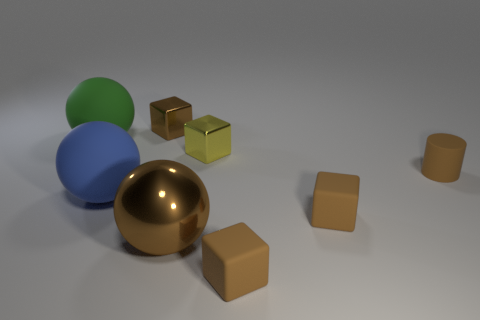Is the number of small brown shiny blocks that are left of the large blue ball the same as the number of blue metal cylinders?
Make the answer very short. Yes. What is the size of the green ball?
Your response must be concise. Large. There is a tiny metallic object that is behind the tiny yellow block; what number of tiny brown blocks are left of it?
Your answer should be compact. 0. What is the shape of the tiny object that is on the right side of the brown ball and behind the brown cylinder?
Give a very brief answer. Cube. What number of tiny things are the same color as the large shiny sphere?
Ensure brevity in your answer.  4. Is there a small yellow block that is to the right of the big matte sphere that is to the right of the green ball that is behind the blue matte ball?
Offer a terse response. Yes. What is the size of the block that is right of the metal ball and behind the tiny brown cylinder?
Your answer should be compact. Small. What number of things are the same material as the small yellow cube?
Your answer should be compact. 2. How many spheres are either tiny brown shiny things or big yellow metal objects?
Keep it short and to the point. 0. What is the size of the shiny thing that is to the left of the big thing that is right of the brown shiny object that is behind the big green matte ball?
Offer a terse response. Small. 